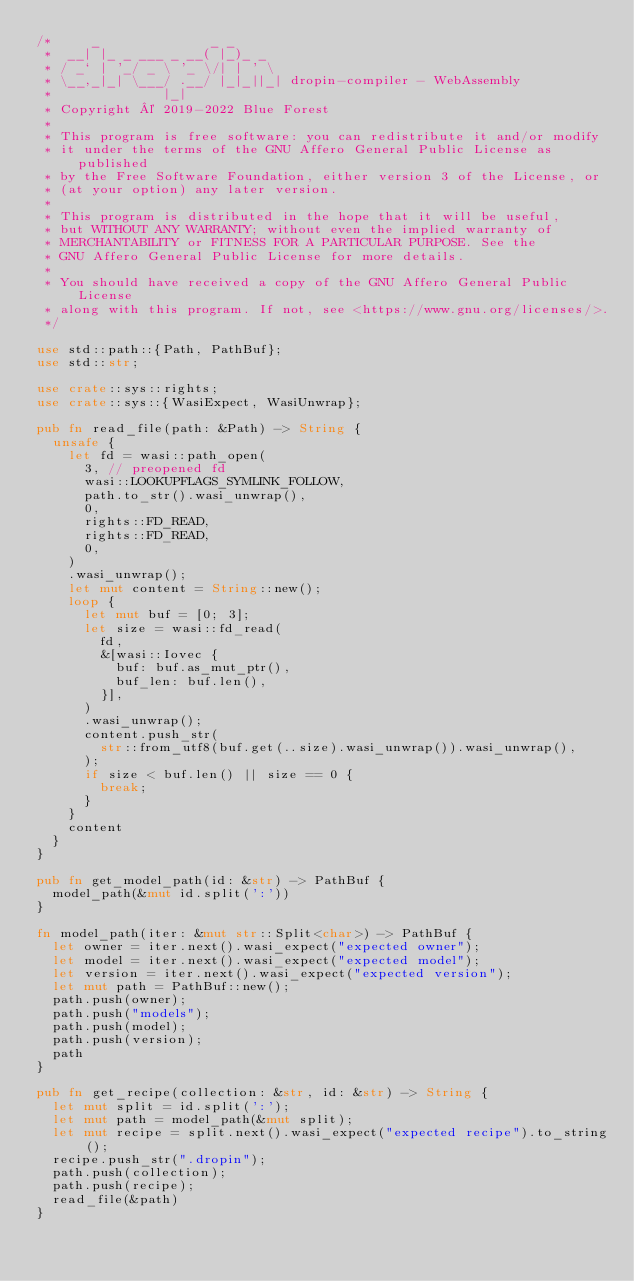Convert code to text. <code><loc_0><loc_0><loc_500><loc_500><_Rust_>/*     _              _ _
 *  __| |_ _ ___ _ __( |_)_ _
 * / _` | '_/ _ \ '_ \/| | ' \
 * \__,_|_| \___/ .__/ |_|_||_| dropin-compiler - WebAssembly
 *              |_|
 * Copyright © 2019-2022 Blue Forest
 *
 * This program is free software: you can redistribute it and/or modify
 * it under the terms of the GNU Affero General Public License as published
 * by the Free Software Foundation, either version 3 of the License, or
 * (at your option) any later version.
 *
 * This program is distributed in the hope that it will be useful,
 * but WITHOUT ANY WARRANTY; without even the implied warranty of
 * MERCHANTABILITY or FITNESS FOR A PARTICULAR PURPOSE. See the
 * GNU Affero General Public License for more details.
 *
 * You should have received a copy of the GNU Affero General Public License
 * along with this program. If not, see <https://www.gnu.org/licenses/>.
 */

use std::path::{Path, PathBuf};
use std::str;

use crate::sys::rights;
use crate::sys::{WasiExpect, WasiUnwrap};

pub fn read_file(path: &Path) -> String {
	unsafe {
		let fd = wasi::path_open(
			3, // preopened fd
			wasi::LOOKUPFLAGS_SYMLINK_FOLLOW,
			path.to_str().wasi_unwrap(),
			0,
			rights::FD_READ,
			rights::FD_READ,
			0,
		)
		.wasi_unwrap();
		let mut content = String::new();
		loop {
			let mut buf = [0; 3];
			let size = wasi::fd_read(
				fd,
				&[wasi::Iovec {
					buf: buf.as_mut_ptr(),
					buf_len: buf.len(),
				}],
			)
			.wasi_unwrap();
			content.push_str(
				str::from_utf8(buf.get(..size).wasi_unwrap()).wasi_unwrap(),
			);
			if size < buf.len() || size == 0 {
				break;
			}
		}
		content
	}
}

pub fn get_model_path(id: &str) -> PathBuf {
	model_path(&mut id.split(':'))
}

fn model_path(iter: &mut str::Split<char>) -> PathBuf {
	let owner = iter.next().wasi_expect("expected owner");
	let model = iter.next().wasi_expect("expected model");
	let version = iter.next().wasi_expect("expected version");
	let mut path = PathBuf::new();
	path.push(owner);
	path.push("models");
	path.push(model);
	path.push(version);
	path
}

pub fn get_recipe(collection: &str, id: &str) -> String {
	let mut split = id.split(':');
	let mut path = model_path(&mut split);
	let mut recipe = split.next().wasi_expect("expected recipe").to_string();
	recipe.push_str(".dropin");
	path.push(collection);
	path.push(recipe);
	read_file(&path)
}
</code> 